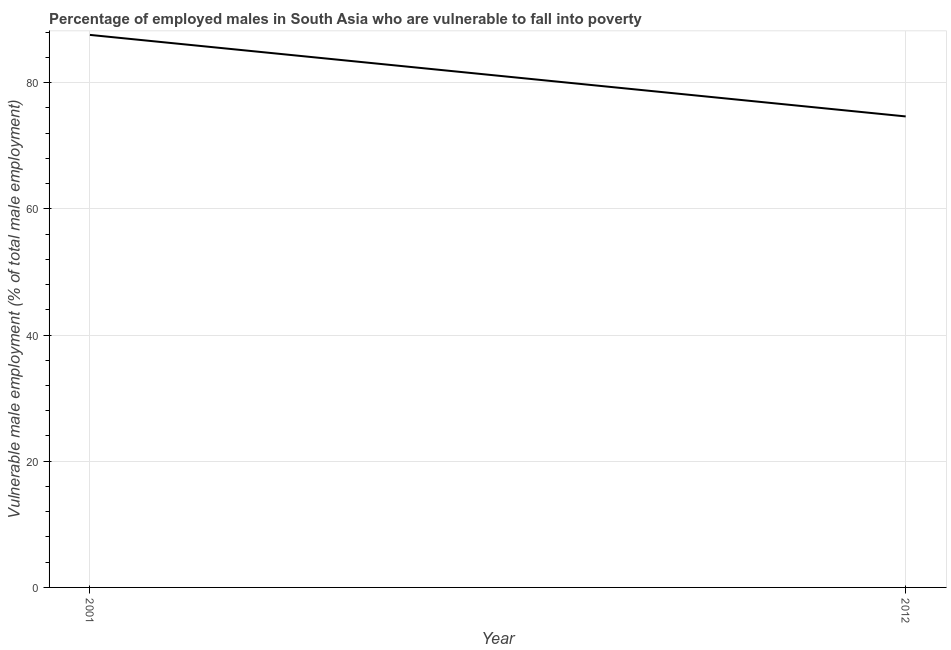What is the percentage of employed males who are vulnerable to fall into poverty in 2012?
Provide a short and direct response. 74.64. Across all years, what is the maximum percentage of employed males who are vulnerable to fall into poverty?
Provide a short and direct response. 87.56. Across all years, what is the minimum percentage of employed males who are vulnerable to fall into poverty?
Keep it short and to the point. 74.64. In which year was the percentage of employed males who are vulnerable to fall into poverty minimum?
Your answer should be very brief. 2012. What is the sum of the percentage of employed males who are vulnerable to fall into poverty?
Keep it short and to the point. 162.19. What is the difference between the percentage of employed males who are vulnerable to fall into poverty in 2001 and 2012?
Keep it short and to the point. 12.92. What is the average percentage of employed males who are vulnerable to fall into poverty per year?
Provide a succinct answer. 81.1. What is the median percentage of employed males who are vulnerable to fall into poverty?
Make the answer very short. 81.1. In how many years, is the percentage of employed males who are vulnerable to fall into poverty greater than 32 %?
Offer a terse response. 2. What is the ratio of the percentage of employed males who are vulnerable to fall into poverty in 2001 to that in 2012?
Offer a very short reply. 1.17. In how many years, is the percentage of employed males who are vulnerable to fall into poverty greater than the average percentage of employed males who are vulnerable to fall into poverty taken over all years?
Give a very brief answer. 1. Does the percentage of employed males who are vulnerable to fall into poverty monotonically increase over the years?
Make the answer very short. No. How many lines are there?
Your response must be concise. 1. What is the difference between two consecutive major ticks on the Y-axis?
Your response must be concise. 20. Are the values on the major ticks of Y-axis written in scientific E-notation?
Keep it short and to the point. No. What is the title of the graph?
Your answer should be compact. Percentage of employed males in South Asia who are vulnerable to fall into poverty. What is the label or title of the Y-axis?
Your answer should be very brief. Vulnerable male employment (% of total male employment). What is the Vulnerable male employment (% of total male employment) in 2001?
Your answer should be very brief. 87.56. What is the Vulnerable male employment (% of total male employment) of 2012?
Provide a succinct answer. 74.64. What is the difference between the Vulnerable male employment (% of total male employment) in 2001 and 2012?
Your answer should be compact. 12.92. What is the ratio of the Vulnerable male employment (% of total male employment) in 2001 to that in 2012?
Make the answer very short. 1.17. 